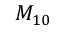Convert formula to latex. <formula><loc_0><loc_0><loc_500><loc_500>M _ { 1 0 }</formula> 